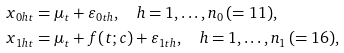<formula> <loc_0><loc_0><loc_500><loc_500>& x _ { 0 h t } = \mu _ { t } + \varepsilon _ { 0 t h } , \quad h = 1 , \dots , n _ { 0 } \, ( = 1 1 ) , \\ & x _ { 1 h t } = \mu _ { t } + f ( t ; c ) + \varepsilon _ { 1 t h } , \quad h = 1 , \dots , n _ { 1 } \, ( = 1 6 ) ,</formula> 